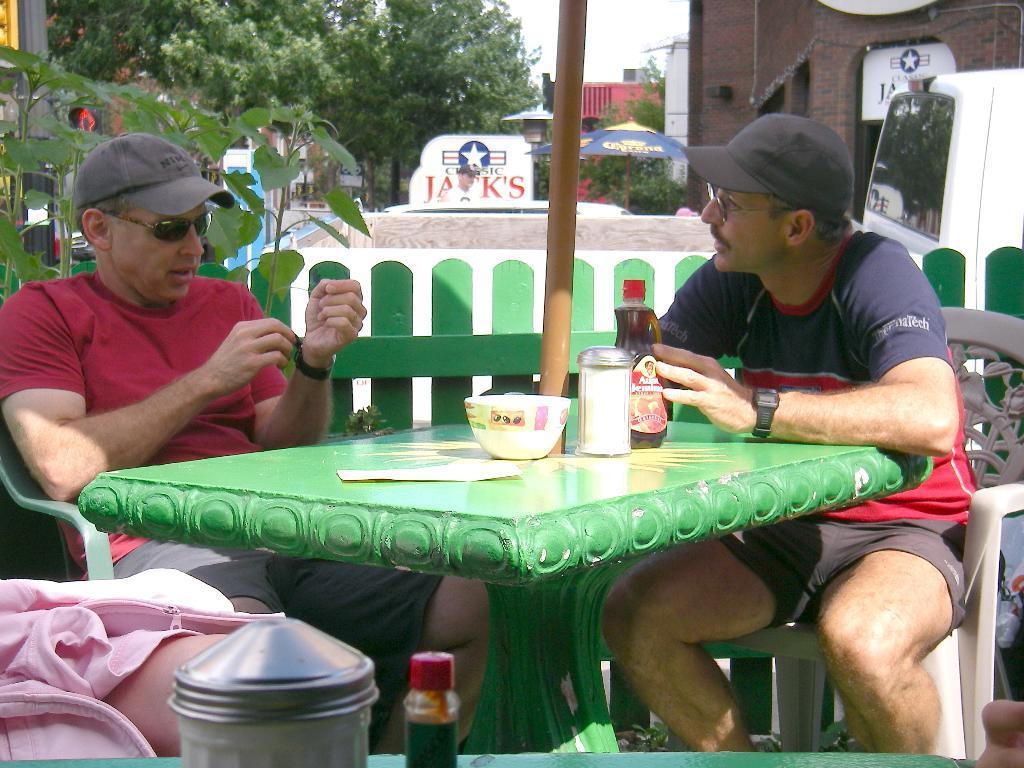Can you describe this image briefly? There are two men wearing caps and sitting in the chairs in front of a table, on which a paper, bowl, bottles were placed. Both of them wearing spectacles. In the background there are some trees and a sky here. 